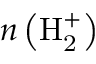Convert formula to latex. <formula><loc_0><loc_0><loc_500><loc_500>n \left ( H _ { 2 } ^ { + } \right )</formula> 